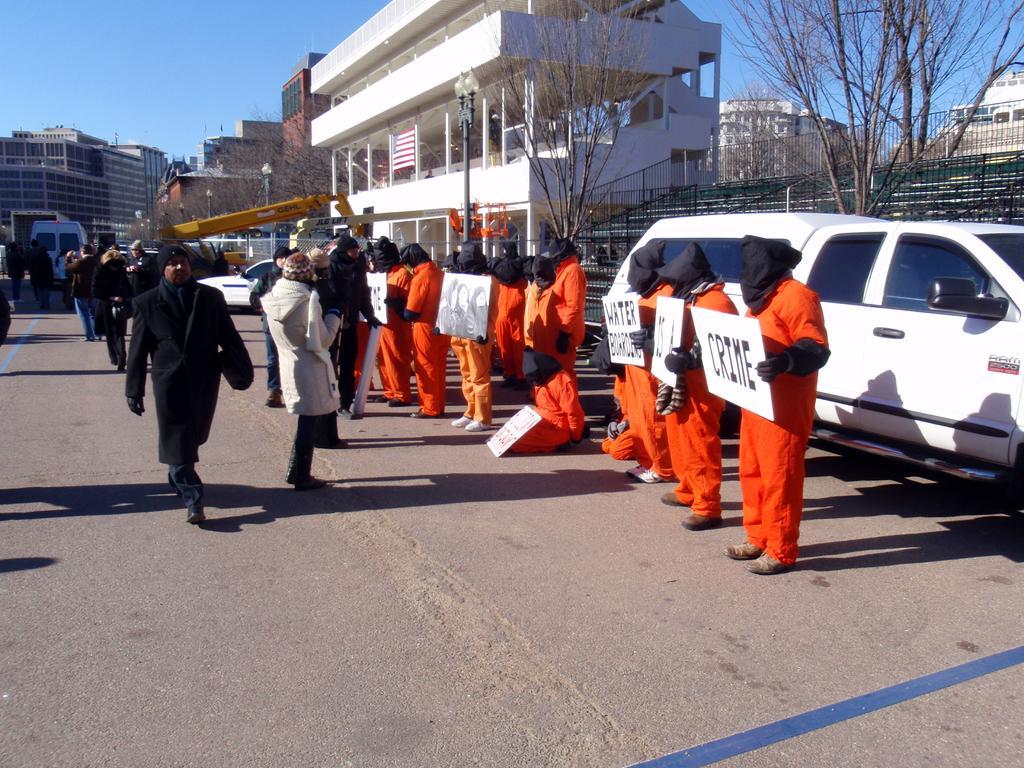Can you describe this image briefly? In this picture we can see some prisoners wearing orange color t-shirt, standing on the road and holding the white boards. Behind there are some persons standing and watching them. In the background there is a white building, cars, trees and railing. 